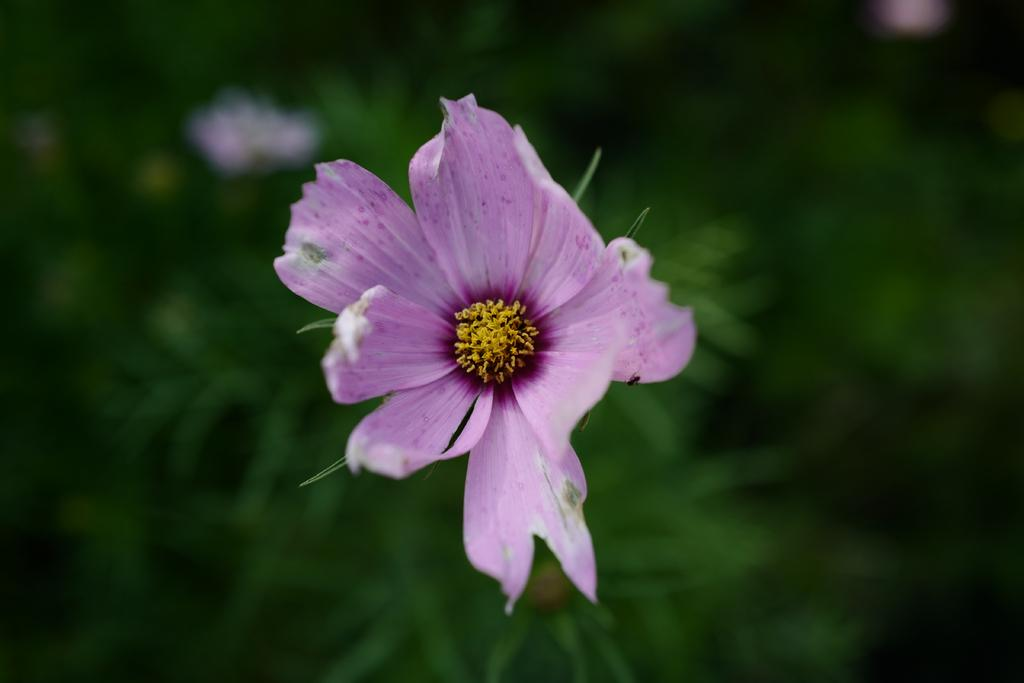What type of flower is in the image? There is a purple color flower in the image. Are there any unopened parts of the flower visible? Yes, the flower has flower buds. What color is the background of the image? The background is green and blurred. Can you see a girl giving a company a kiss in the image? No, there is no girl or company present in the image, and no kissing is depicted. 